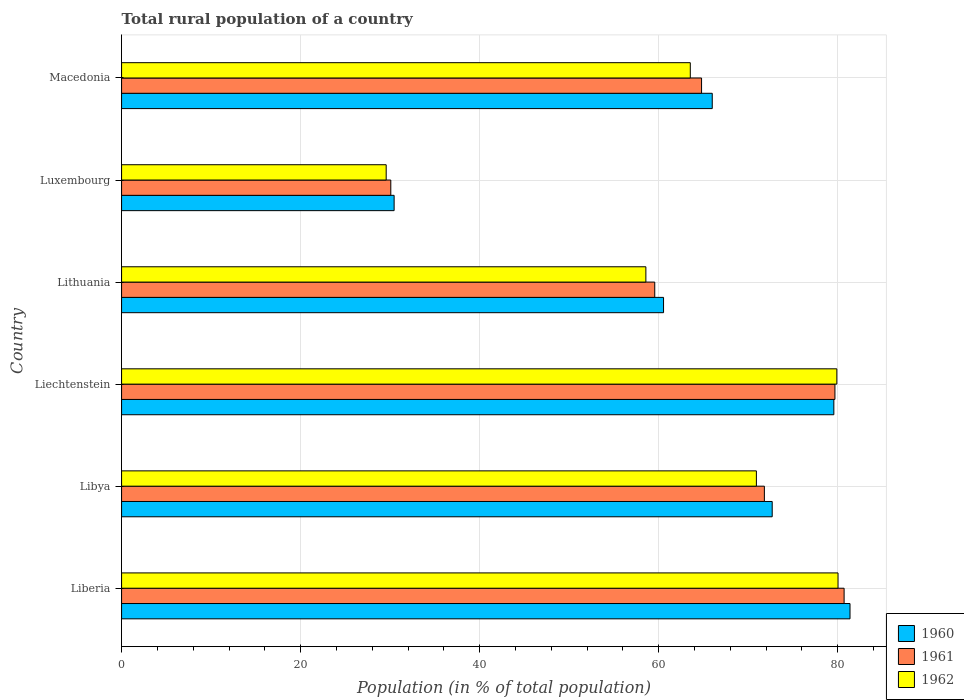How many different coloured bars are there?
Keep it short and to the point. 3. Are the number of bars on each tick of the Y-axis equal?
Keep it short and to the point. Yes. How many bars are there on the 4th tick from the top?
Your answer should be very brief. 3. How many bars are there on the 5th tick from the bottom?
Offer a very short reply. 3. What is the label of the 6th group of bars from the top?
Your answer should be very brief. Liberia. In how many cases, is the number of bars for a given country not equal to the number of legend labels?
Keep it short and to the point. 0. What is the rural population in 1962 in Libya?
Offer a terse response. 70.91. Across all countries, what is the maximum rural population in 1961?
Keep it short and to the point. 80.71. Across all countries, what is the minimum rural population in 1962?
Offer a very short reply. 29.56. In which country was the rural population in 1960 maximum?
Offer a terse response. Liberia. In which country was the rural population in 1960 minimum?
Provide a short and direct response. Luxembourg. What is the total rural population in 1960 in the graph?
Provide a succinct answer. 390.57. What is the difference between the rural population in 1960 in Libya and that in Macedonia?
Provide a short and direct response. 6.7. What is the difference between the rural population in 1961 in Libya and the rural population in 1962 in Macedonia?
Your answer should be compact. 8.28. What is the average rural population in 1962 per country?
Your answer should be very brief. 63.75. What is the difference between the rural population in 1961 and rural population in 1962 in Libya?
Give a very brief answer. 0.89. What is the ratio of the rural population in 1960 in Libya to that in Liechtenstein?
Make the answer very short. 0.91. Is the difference between the rural population in 1961 in Luxembourg and Macedonia greater than the difference between the rural population in 1962 in Luxembourg and Macedonia?
Ensure brevity in your answer.  No. What is the difference between the highest and the second highest rural population in 1960?
Offer a terse response. 1.8. What is the difference between the highest and the lowest rural population in 1962?
Your response must be concise. 50.47. How many bars are there?
Your response must be concise. 18. Are all the bars in the graph horizontal?
Your response must be concise. Yes. Are the values on the major ticks of X-axis written in scientific E-notation?
Offer a terse response. No. Does the graph contain any zero values?
Your response must be concise. No. Does the graph contain grids?
Ensure brevity in your answer.  Yes. Where does the legend appear in the graph?
Your answer should be compact. Bottom right. How many legend labels are there?
Your response must be concise. 3. How are the legend labels stacked?
Your response must be concise. Vertical. What is the title of the graph?
Ensure brevity in your answer.  Total rural population of a country. Does "1962" appear as one of the legend labels in the graph?
Provide a short and direct response. Yes. What is the label or title of the X-axis?
Give a very brief answer. Population (in % of total population). What is the Population (in % of total population) of 1960 in Liberia?
Your answer should be compact. 81.37. What is the Population (in % of total population) of 1961 in Liberia?
Provide a succinct answer. 80.71. What is the Population (in % of total population) of 1962 in Liberia?
Offer a very short reply. 80.03. What is the Population (in % of total population) of 1960 in Libya?
Your response must be concise. 72.68. What is the Population (in % of total population) in 1961 in Libya?
Your answer should be very brief. 71.8. What is the Population (in % of total population) of 1962 in Libya?
Offer a very short reply. 70.91. What is the Population (in % of total population) of 1960 in Liechtenstein?
Make the answer very short. 79.56. What is the Population (in % of total population) in 1961 in Liechtenstein?
Ensure brevity in your answer.  79.69. What is the Population (in % of total population) in 1962 in Liechtenstein?
Provide a short and direct response. 79.9. What is the Population (in % of total population) of 1960 in Lithuania?
Give a very brief answer. 60.54. What is the Population (in % of total population) of 1961 in Lithuania?
Give a very brief answer. 59.56. What is the Population (in % of total population) of 1962 in Lithuania?
Keep it short and to the point. 58.56. What is the Population (in % of total population) in 1960 in Luxembourg?
Provide a succinct answer. 30.44. What is the Population (in % of total population) in 1961 in Luxembourg?
Your response must be concise. 30.07. What is the Population (in % of total population) of 1962 in Luxembourg?
Provide a short and direct response. 29.56. What is the Population (in % of total population) in 1960 in Macedonia?
Provide a short and direct response. 65.98. What is the Population (in % of total population) of 1961 in Macedonia?
Your response must be concise. 64.79. What is the Population (in % of total population) in 1962 in Macedonia?
Make the answer very short. 63.53. Across all countries, what is the maximum Population (in % of total population) of 1960?
Make the answer very short. 81.37. Across all countries, what is the maximum Population (in % of total population) in 1961?
Keep it short and to the point. 80.71. Across all countries, what is the maximum Population (in % of total population) of 1962?
Offer a terse response. 80.03. Across all countries, what is the minimum Population (in % of total population) in 1960?
Provide a short and direct response. 30.44. Across all countries, what is the minimum Population (in % of total population) in 1961?
Give a very brief answer. 30.07. Across all countries, what is the minimum Population (in % of total population) of 1962?
Keep it short and to the point. 29.56. What is the total Population (in % of total population) in 1960 in the graph?
Your answer should be very brief. 390.57. What is the total Population (in % of total population) of 1961 in the graph?
Keep it short and to the point. 386.61. What is the total Population (in % of total population) of 1962 in the graph?
Provide a short and direct response. 382.49. What is the difference between the Population (in % of total population) in 1960 in Liberia and that in Libya?
Offer a terse response. 8.69. What is the difference between the Population (in % of total population) of 1961 in Liberia and that in Libya?
Provide a succinct answer. 8.91. What is the difference between the Population (in % of total population) of 1962 in Liberia and that in Libya?
Provide a succinct answer. 9.12. What is the difference between the Population (in % of total population) in 1960 in Liberia and that in Liechtenstein?
Offer a very short reply. 1.8. What is the difference between the Population (in % of total population) of 1961 in Liberia and that in Liechtenstein?
Ensure brevity in your answer.  1.02. What is the difference between the Population (in % of total population) in 1962 in Liberia and that in Liechtenstein?
Offer a very short reply. 0.13. What is the difference between the Population (in % of total population) in 1960 in Liberia and that in Lithuania?
Your answer should be compact. 20.83. What is the difference between the Population (in % of total population) in 1961 in Liberia and that in Lithuania?
Make the answer very short. 21.15. What is the difference between the Population (in % of total population) of 1962 in Liberia and that in Lithuania?
Offer a terse response. 21.47. What is the difference between the Population (in % of total population) of 1960 in Liberia and that in Luxembourg?
Make the answer very short. 50.92. What is the difference between the Population (in % of total population) of 1961 in Liberia and that in Luxembourg?
Offer a very short reply. 50.64. What is the difference between the Population (in % of total population) of 1962 in Liberia and that in Luxembourg?
Offer a very short reply. 50.47. What is the difference between the Population (in % of total population) of 1960 in Liberia and that in Macedonia?
Offer a very short reply. 15.39. What is the difference between the Population (in % of total population) of 1961 in Liberia and that in Macedonia?
Give a very brief answer. 15.92. What is the difference between the Population (in % of total population) in 1962 in Liberia and that in Macedonia?
Offer a terse response. 16.5. What is the difference between the Population (in % of total population) in 1960 in Libya and that in Liechtenstein?
Give a very brief answer. -6.89. What is the difference between the Population (in % of total population) in 1961 in Libya and that in Liechtenstein?
Give a very brief answer. -7.88. What is the difference between the Population (in % of total population) of 1962 in Libya and that in Liechtenstein?
Provide a short and direct response. -8.99. What is the difference between the Population (in % of total population) in 1960 in Libya and that in Lithuania?
Keep it short and to the point. 12.14. What is the difference between the Population (in % of total population) in 1961 in Libya and that in Lithuania?
Ensure brevity in your answer.  12.25. What is the difference between the Population (in % of total population) of 1962 in Libya and that in Lithuania?
Make the answer very short. 12.35. What is the difference between the Population (in % of total population) in 1960 in Libya and that in Luxembourg?
Provide a succinct answer. 42.23. What is the difference between the Population (in % of total population) of 1961 in Libya and that in Luxembourg?
Make the answer very short. 41.73. What is the difference between the Population (in % of total population) of 1962 in Libya and that in Luxembourg?
Your answer should be compact. 41.35. What is the difference between the Population (in % of total population) in 1960 in Libya and that in Macedonia?
Provide a succinct answer. 6.7. What is the difference between the Population (in % of total population) of 1961 in Libya and that in Macedonia?
Ensure brevity in your answer.  7.02. What is the difference between the Population (in % of total population) of 1962 in Libya and that in Macedonia?
Your answer should be very brief. 7.38. What is the difference between the Population (in % of total population) of 1960 in Liechtenstein and that in Lithuania?
Keep it short and to the point. 19.02. What is the difference between the Population (in % of total population) of 1961 in Liechtenstein and that in Lithuania?
Offer a very short reply. 20.13. What is the difference between the Population (in % of total population) in 1962 in Liechtenstein and that in Lithuania?
Give a very brief answer. 21.33. What is the difference between the Population (in % of total population) of 1960 in Liechtenstein and that in Luxembourg?
Provide a short and direct response. 49.12. What is the difference between the Population (in % of total population) in 1961 in Liechtenstein and that in Luxembourg?
Ensure brevity in your answer.  49.61. What is the difference between the Population (in % of total population) of 1962 in Liechtenstein and that in Luxembourg?
Offer a very short reply. 50.34. What is the difference between the Population (in % of total population) of 1960 in Liechtenstein and that in Macedonia?
Offer a terse response. 13.58. What is the difference between the Population (in % of total population) of 1961 in Liechtenstein and that in Macedonia?
Provide a succinct answer. 14.9. What is the difference between the Population (in % of total population) in 1962 in Liechtenstein and that in Macedonia?
Keep it short and to the point. 16.37. What is the difference between the Population (in % of total population) in 1960 in Lithuania and that in Luxembourg?
Give a very brief answer. 30.1. What is the difference between the Population (in % of total population) of 1961 in Lithuania and that in Luxembourg?
Provide a succinct answer. 29.48. What is the difference between the Population (in % of total population) in 1962 in Lithuania and that in Luxembourg?
Your response must be concise. 29.01. What is the difference between the Population (in % of total population) of 1960 in Lithuania and that in Macedonia?
Your answer should be compact. -5.44. What is the difference between the Population (in % of total population) of 1961 in Lithuania and that in Macedonia?
Your response must be concise. -5.23. What is the difference between the Population (in % of total population) in 1962 in Lithuania and that in Macedonia?
Offer a very short reply. -4.96. What is the difference between the Population (in % of total population) of 1960 in Luxembourg and that in Macedonia?
Your answer should be very brief. -35.54. What is the difference between the Population (in % of total population) in 1961 in Luxembourg and that in Macedonia?
Provide a succinct answer. -34.71. What is the difference between the Population (in % of total population) in 1962 in Luxembourg and that in Macedonia?
Your answer should be compact. -33.97. What is the difference between the Population (in % of total population) in 1960 in Liberia and the Population (in % of total population) in 1961 in Libya?
Keep it short and to the point. 9.56. What is the difference between the Population (in % of total population) of 1960 in Liberia and the Population (in % of total population) of 1962 in Libya?
Offer a terse response. 10.46. What is the difference between the Population (in % of total population) of 1961 in Liberia and the Population (in % of total population) of 1962 in Libya?
Your response must be concise. 9.8. What is the difference between the Population (in % of total population) of 1960 in Liberia and the Population (in % of total population) of 1961 in Liechtenstein?
Offer a terse response. 1.68. What is the difference between the Population (in % of total population) of 1960 in Liberia and the Population (in % of total population) of 1962 in Liechtenstein?
Ensure brevity in your answer.  1.47. What is the difference between the Population (in % of total population) of 1961 in Liberia and the Population (in % of total population) of 1962 in Liechtenstein?
Provide a succinct answer. 0.81. What is the difference between the Population (in % of total population) of 1960 in Liberia and the Population (in % of total population) of 1961 in Lithuania?
Make the answer very short. 21.81. What is the difference between the Population (in % of total population) in 1960 in Liberia and the Population (in % of total population) in 1962 in Lithuania?
Your answer should be compact. 22.8. What is the difference between the Population (in % of total population) of 1961 in Liberia and the Population (in % of total population) of 1962 in Lithuania?
Give a very brief answer. 22.14. What is the difference between the Population (in % of total population) in 1960 in Liberia and the Population (in % of total population) in 1961 in Luxembourg?
Make the answer very short. 51.3. What is the difference between the Population (in % of total population) in 1960 in Liberia and the Population (in % of total population) in 1962 in Luxembourg?
Your response must be concise. 51.81. What is the difference between the Population (in % of total population) in 1961 in Liberia and the Population (in % of total population) in 1962 in Luxembourg?
Make the answer very short. 51.15. What is the difference between the Population (in % of total population) in 1960 in Liberia and the Population (in % of total population) in 1961 in Macedonia?
Make the answer very short. 16.58. What is the difference between the Population (in % of total population) in 1960 in Liberia and the Population (in % of total population) in 1962 in Macedonia?
Your response must be concise. 17.84. What is the difference between the Population (in % of total population) of 1961 in Liberia and the Population (in % of total population) of 1962 in Macedonia?
Your answer should be compact. 17.18. What is the difference between the Population (in % of total population) in 1960 in Libya and the Population (in % of total population) in 1961 in Liechtenstein?
Keep it short and to the point. -7.01. What is the difference between the Population (in % of total population) in 1960 in Libya and the Population (in % of total population) in 1962 in Liechtenstein?
Offer a very short reply. -7.22. What is the difference between the Population (in % of total population) in 1961 in Libya and the Population (in % of total population) in 1962 in Liechtenstein?
Give a very brief answer. -8.1. What is the difference between the Population (in % of total population) in 1960 in Libya and the Population (in % of total population) in 1961 in Lithuania?
Offer a terse response. 13.12. What is the difference between the Population (in % of total population) in 1960 in Libya and the Population (in % of total population) in 1962 in Lithuania?
Offer a very short reply. 14.11. What is the difference between the Population (in % of total population) of 1961 in Libya and the Population (in % of total population) of 1962 in Lithuania?
Offer a terse response. 13.24. What is the difference between the Population (in % of total population) of 1960 in Libya and the Population (in % of total population) of 1961 in Luxembourg?
Ensure brevity in your answer.  42.6. What is the difference between the Population (in % of total population) of 1960 in Libya and the Population (in % of total population) of 1962 in Luxembourg?
Your response must be concise. 43.12. What is the difference between the Population (in % of total population) of 1961 in Libya and the Population (in % of total population) of 1962 in Luxembourg?
Make the answer very short. 42.25. What is the difference between the Population (in % of total population) of 1960 in Libya and the Population (in % of total population) of 1961 in Macedonia?
Offer a very short reply. 7.89. What is the difference between the Population (in % of total population) in 1960 in Libya and the Population (in % of total population) in 1962 in Macedonia?
Your answer should be compact. 9.15. What is the difference between the Population (in % of total population) of 1961 in Libya and the Population (in % of total population) of 1962 in Macedonia?
Your response must be concise. 8.28. What is the difference between the Population (in % of total population) in 1960 in Liechtenstein and the Population (in % of total population) in 1961 in Lithuania?
Ensure brevity in your answer.  20.01. What is the difference between the Population (in % of total population) in 1960 in Liechtenstein and the Population (in % of total population) in 1962 in Lithuania?
Provide a short and direct response. 21. What is the difference between the Population (in % of total population) in 1961 in Liechtenstein and the Population (in % of total population) in 1962 in Lithuania?
Keep it short and to the point. 21.12. What is the difference between the Population (in % of total population) in 1960 in Liechtenstein and the Population (in % of total population) in 1961 in Luxembourg?
Your response must be concise. 49.49. What is the difference between the Population (in % of total population) in 1960 in Liechtenstein and the Population (in % of total population) in 1962 in Luxembourg?
Your answer should be compact. 50.01. What is the difference between the Population (in % of total population) of 1961 in Liechtenstein and the Population (in % of total population) of 1962 in Luxembourg?
Provide a short and direct response. 50.13. What is the difference between the Population (in % of total population) of 1960 in Liechtenstein and the Population (in % of total population) of 1961 in Macedonia?
Ensure brevity in your answer.  14.78. What is the difference between the Population (in % of total population) of 1960 in Liechtenstein and the Population (in % of total population) of 1962 in Macedonia?
Your answer should be compact. 16.04. What is the difference between the Population (in % of total population) of 1961 in Liechtenstein and the Population (in % of total population) of 1962 in Macedonia?
Ensure brevity in your answer.  16.16. What is the difference between the Population (in % of total population) of 1960 in Lithuania and the Population (in % of total population) of 1961 in Luxembourg?
Make the answer very short. 30.47. What is the difference between the Population (in % of total population) in 1960 in Lithuania and the Population (in % of total population) in 1962 in Luxembourg?
Provide a short and direct response. 30.98. What is the difference between the Population (in % of total population) in 1960 in Lithuania and the Population (in % of total population) in 1961 in Macedonia?
Keep it short and to the point. -4.25. What is the difference between the Population (in % of total population) in 1960 in Lithuania and the Population (in % of total population) in 1962 in Macedonia?
Offer a very short reply. -2.99. What is the difference between the Population (in % of total population) in 1961 in Lithuania and the Population (in % of total population) in 1962 in Macedonia?
Your answer should be compact. -3.97. What is the difference between the Population (in % of total population) in 1960 in Luxembourg and the Population (in % of total population) in 1961 in Macedonia?
Provide a short and direct response. -34.34. What is the difference between the Population (in % of total population) in 1960 in Luxembourg and the Population (in % of total population) in 1962 in Macedonia?
Give a very brief answer. -33.08. What is the difference between the Population (in % of total population) in 1961 in Luxembourg and the Population (in % of total population) in 1962 in Macedonia?
Offer a very short reply. -33.45. What is the average Population (in % of total population) in 1960 per country?
Provide a short and direct response. 65.1. What is the average Population (in % of total population) in 1961 per country?
Your answer should be compact. 64.44. What is the average Population (in % of total population) of 1962 per country?
Provide a short and direct response. 63.75. What is the difference between the Population (in % of total population) of 1960 and Population (in % of total population) of 1961 in Liberia?
Your response must be concise. 0.66. What is the difference between the Population (in % of total population) in 1960 and Population (in % of total population) in 1962 in Liberia?
Offer a terse response. 1.34. What is the difference between the Population (in % of total population) of 1961 and Population (in % of total population) of 1962 in Liberia?
Offer a terse response. 0.68. What is the difference between the Population (in % of total population) in 1960 and Population (in % of total population) in 1961 in Libya?
Provide a succinct answer. 0.87. What is the difference between the Population (in % of total population) in 1960 and Population (in % of total population) in 1962 in Libya?
Provide a succinct answer. 1.77. What is the difference between the Population (in % of total population) in 1961 and Population (in % of total population) in 1962 in Libya?
Keep it short and to the point. 0.89. What is the difference between the Population (in % of total population) of 1960 and Population (in % of total population) of 1961 in Liechtenstein?
Offer a very short reply. -0.12. What is the difference between the Population (in % of total population) of 1960 and Population (in % of total population) of 1962 in Liechtenstein?
Offer a very short reply. -0.34. What is the difference between the Population (in % of total population) of 1961 and Population (in % of total population) of 1962 in Liechtenstein?
Your response must be concise. -0.21. What is the difference between the Population (in % of total population) of 1960 and Population (in % of total population) of 1961 in Lithuania?
Keep it short and to the point. 0.98. What is the difference between the Population (in % of total population) in 1960 and Population (in % of total population) in 1962 in Lithuania?
Your response must be concise. 1.98. What is the difference between the Population (in % of total population) of 1960 and Population (in % of total population) of 1961 in Luxembourg?
Your response must be concise. 0.37. What is the difference between the Population (in % of total population) in 1960 and Population (in % of total population) in 1962 in Luxembourg?
Your response must be concise. 0.89. What is the difference between the Population (in % of total population) of 1961 and Population (in % of total population) of 1962 in Luxembourg?
Keep it short and to the point. 0.52. What is the difference between the Population (in % of total population) of 1960 and Population (in % of total population) of 1961 in Macedonia?
Provide a short and direct response. 1.19. What is the difference between the Population (in % of total population) of 1960 and Population (in % of total population) of 1962 in Macedonia?
Ensure brevity in your answer.  2.45. What is the difference between the Population (in % of total population) in 1961 and Population (in % of total population) in 1962 in Macedonia?
Provide a succinct answer. 1.26. What is the ratio of the Population (in % of total population) of 1960 in Liberia to that in Libya?
Provide a short and direct response. 1.12. What is the ratio of the Population (in % of total population) in 1961 in Liberia to that in Libya?
Your response must be concise. 1.12. What is the ratio of the Population (in % of total population) in 1962 in Liberia to that in Libya?
Make the answer very short. 1.13. What is the ratio of the Population (in % of total population) in 1960 in Liberia to that in Liechtenstein?
Offer a very short reply. 1.02. What is the ratio of the Population (in % of total population) in 1961 in Liberia to that in Liechtenstein?
Offer a very short reply. 1.01. What is the ratio of the Population (in % of total population) of 1960 in Liberia to that in Lithuania?
Keep it short and to the point. 1.34. What is the ratio of the Population (in % of total population) of 1961 in Liberia to that in Lithuania?
Your answer should be compact. 1.36. What is the ratio of the Population (in % of total population) of 1962 in Liberia to that in Lithuania?
Offer a very short reply. 1.37. What is the ratio of the Population (in % of total population) of 1960 in Liberia to that in Luxembourg?
Keep it short and to the point. 2.67. What is the ratio of the Population (in % of total population) in 1961 in Liberia to that in Luxembourg?
Provide a succinct answer. 2.68. What is the ratio of the Population (in % of total population) in 1962 in Liberia to that in Luxembourg?
Your answer should be compact. 2.71. What is the ratio of the Population (in % of total population) in 1960 in Liberia to that in Macedonia?
Make the answer very short. 1.23. What is the ratio of the Population (in % of total population) of 1961 in Liberia to that in Macedonia?
Provide a short and direct response. 1.25. What is the ratio of the Population (in % of total population) in 1962 in Liberia to that in Macedonia?
Give a very brief answer. 1.26. What is the ratio of the Population (in % of total population) in 1960 in Libya to that in Liechtenstein?
Provide a succinct answer. 0.91. What is the ratio of the Population (in % of total population) in 1961 in Libya to that in Liechtenstein?
Ensure brevity in your answer.  0.9. What is the ratio of the Population (in % of total population) in 1962 in Libya to that in Liechtenstein?
Ensure brevity in your answer.  0.89. What is the ratio of the Population (in % of total population) of 1960 in Libya to that in Lithuania?
Provide a short and direct response. 1.2. What is the ratio of the Population (in % of total population) of 1961 in Libya to that in Lithuania?
Keep it short and to the point. 1.21. What is the ratio of the Population (in % of total population) in 1962 in Libya to that in Lithuania?
Make the answer very short. 1.21. What is the ratio of the Population (in % of total population) of 1960 in Libya to that in Luxembourg?
Give a very brief answer. 2.39. What is the ratio of the Population (in % of total population) of 1961 in Libya to that in Luxembourg?
Your answer should be very brief. 2.39. What is the ratio of the Population (in % of total population) of 1962 in Libya to that in Luxembourg?
Offer a very short reply. 2.4. What is the ratio of the Population (in % of total population) in 1960 in Libya to that in Macedonia?
Make the answer very short. 1.1. What is the ratio of the Population (in % of total population) of 1961 in Libya to that in Macedonia?
Ensure brevity in your answer.  1.11. What is the ratio of the Population (in % of total population) in 1962 in Libya to that in Macedonia?
Provide a short and direct response. 1.12. What is the ratio of the Population (in % of total population) of 1960 in Liechtenstein to that in Lithuania?
Give a very brief answer. 1.31. What is the ratio of the Population (in % of total population) in 1961 in Liechtenstein to that in Lithuania?
Provide a succinct answer. 1.34. What is the ratio of the Population (in % of total population) in 1962 in Liechtenstein to that in Lithuania?
Your answer should be compact. 1.36. What is the ratio of the Population (in % of total population) of 1960 in Liechtenstein to that in Luxembourg?
Your answer should be compact. 2.61. What is the ratio of the Population (in % of total population) in 1961 in Liechtenstein to that in Luxembourg?
Provide a succinct answer. 2.65. What is the ratio of the Population (in % of total population) of 1962 in Liechtenstein to that in Luxembourg?
Ensure brevity in your answer.  2.7. What is the ratio of the Population (in % of total population) of 1960 in Liechtenstein to that in Macedonia?
Make the answer very short. 1.21. What is the ratio of the Population (in % of total population) of 1961 in Liechtenstein to that in Macedonia?
Your answer should be very brief. 1.23. What is the ratio of the Population (in % of total population) of 1962 in Liechtenstein to that in Macedonia?
Offer a terse response. 1.26. What is the ratio of the Population (in % of total population) in 1960 in Lithuania to that in Luxembourg?
Ensure brevity in your answer.  1.99. What is the ratio of the Population (in % of total population) of 1961 in Lithuania to that in Luxembourg?
Your answer should be compact. 1.98. What is the ratio of the Population (in % of total population) of 1962 in Lithuania to that in Luxembourg?
Ensure brevity in your answer.  1.98. What is the ratio of the Population (in % of total population) in 1960 in Lithuania to that in Macedonia?
Make the answer very short. 0.92. What is the ratio of the Population (in % of total population) of 1961 in Lithuania to that in Macedonia?
Keep it short and to the point. 0.92. What is the ratio of the Population (in % of total population) in 1962 in Lithuania to that in Macedonia?
Your answer should be very brief. 0.92. What is the ratio of the Population (in % of total population) of 1960 in Luxembourg to that in Macedonia?
Offer a terse response. 0.46. What is the ratio of the Population (in % of total population) in 1961 in Luxembourg to that in Macedonia?
Keep it short and to the point. 0.46. What is the ratio of the Population (in % of total population) of 1962 in Luxembourg to that in Macedonia?
Give a very brief answer. 0.47. What is the difference between the highest and the second highest Population (in % of total population) in 1960?
Ensure brevity in your answer.  1.8. What is the difference between the highest and the second highest Population (in % of total population) in 1962?
Your response must be concise. 0.13. What is the difference between the highest and the lowest Population (in % of total population) in 1960?
Ensure brevity in your answer.  50.92. What is the difference between the highest and the lowest Population (in % of total population) of 1961?
Ensure brevity in your answer.  50.64. What is the difference between the highest and the lowest Population (in % of total population) in 1962?
Offer a terse response. 50.47. 